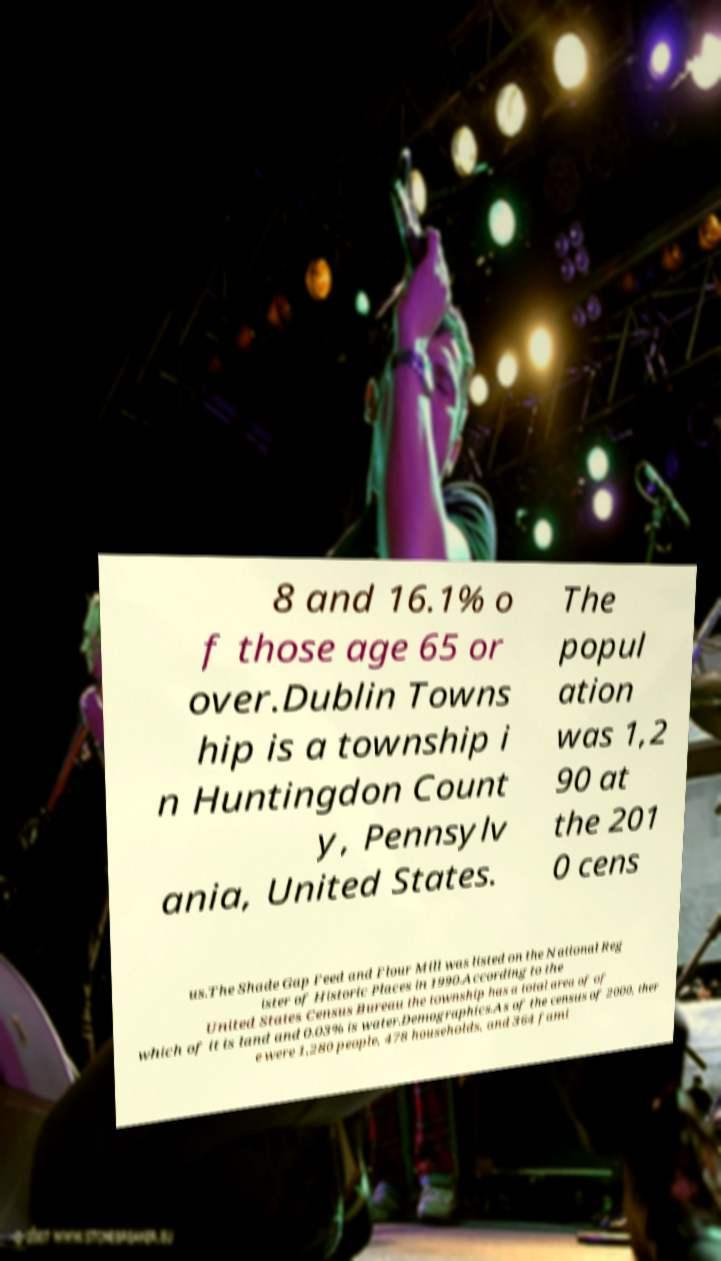What messages or text are displayed in this image? I need them in a readable, typed format. 8 and 16.1% o f those age 65 or over.Dublin Towns hip is a township i n Huntingdon Count y, Pennsylv ania, United States. The popul ation was 1,2 90 at the 201 0 cens us.The Shade Gap Feed and Flour Mill was listed on the National Reg ister of Historic Places in 1990.According to the United States Census Bureau the township has a total area of of which of it is land and 0.03% is water.Demographics.As of the census of 2000, ther e were 1,280 people, 478 households, and 364 fami 